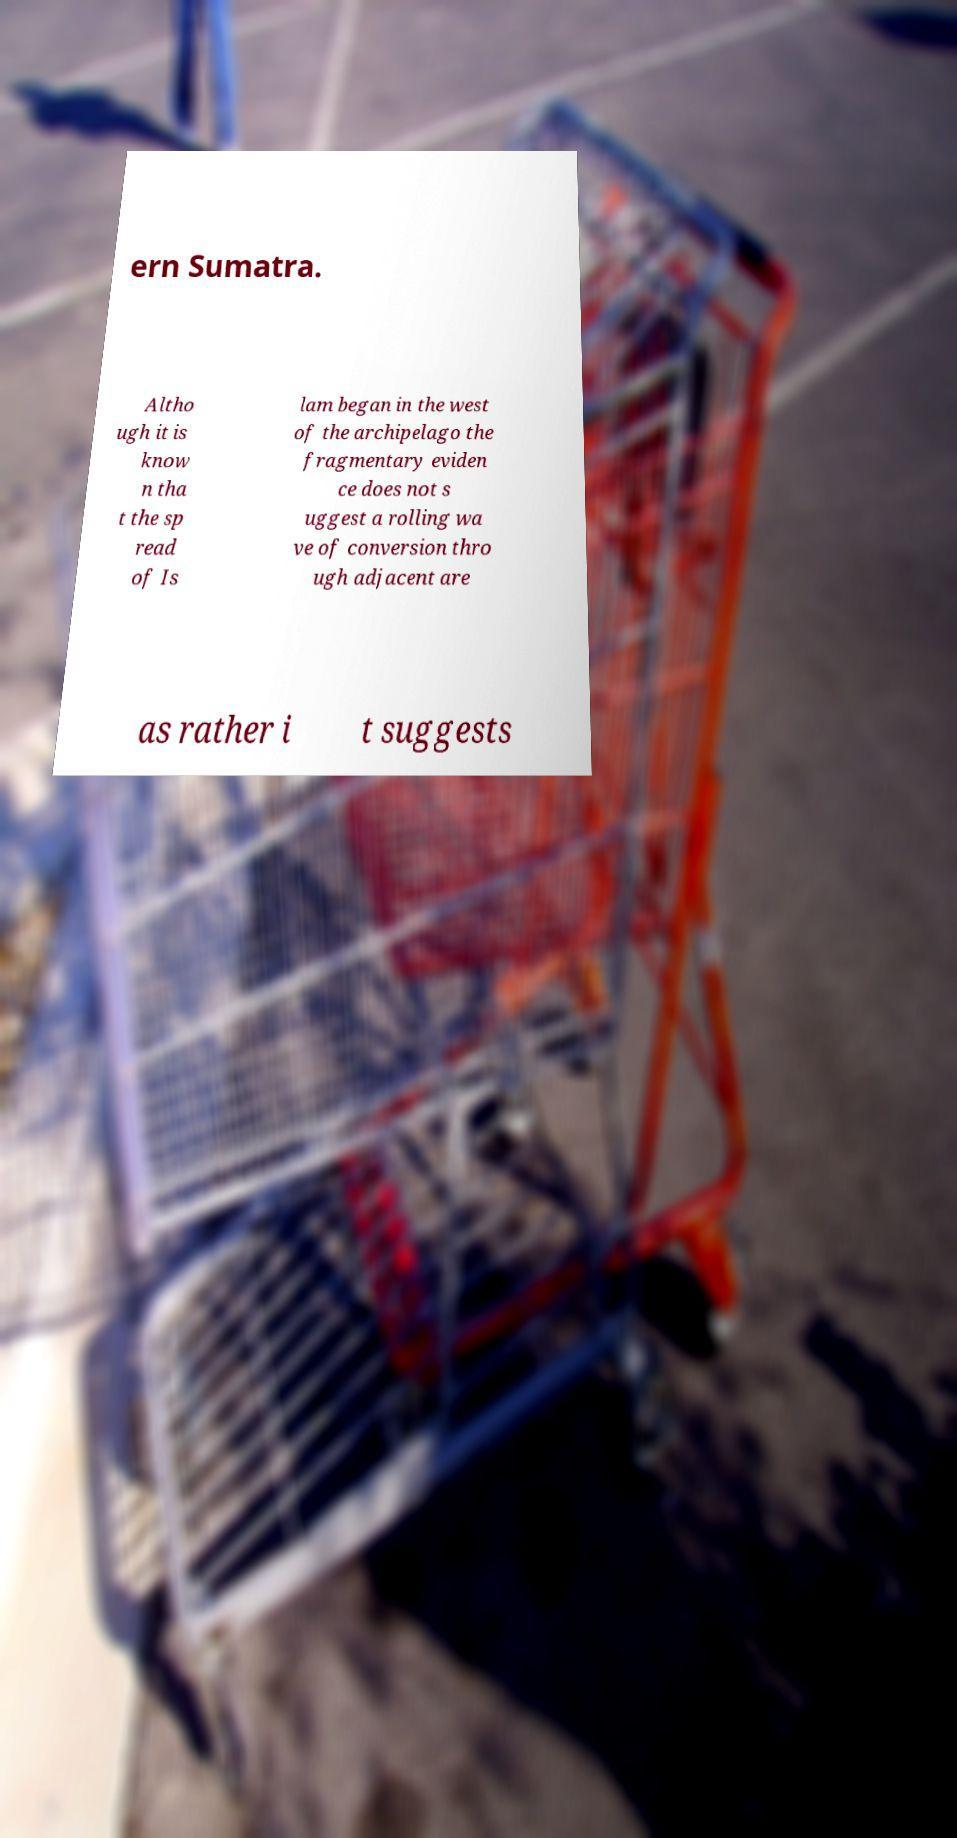Please identify and transcribe the text found in this image. ern Sumatra. Altho ugh it is know n tha t the sp read of Is lam began in the west of the archipelago the fragmentary eviden ce does not s uggest a rolling wa ve of conversion thro ugh adjacent are as rather i t suggests 